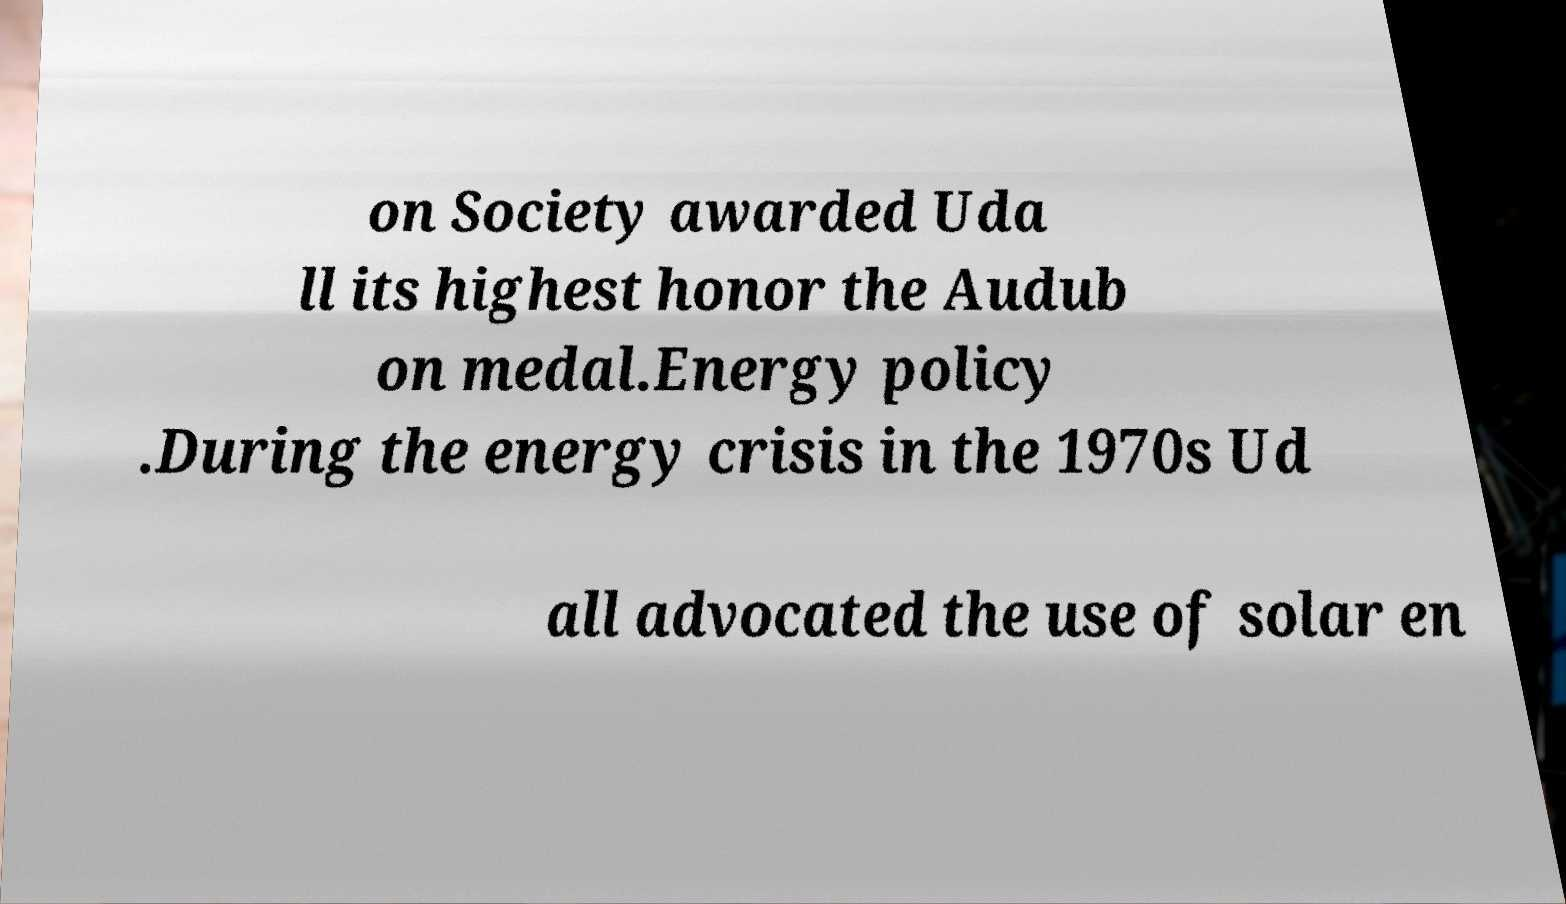For documentation purposes, I need the text within this image transcribed. Could you provide that? on Society awarded Uda ll its highest honor the Audub on medal.Energy policy .During the energy crisis in the 1970s Ud all advocated the use of solar en 